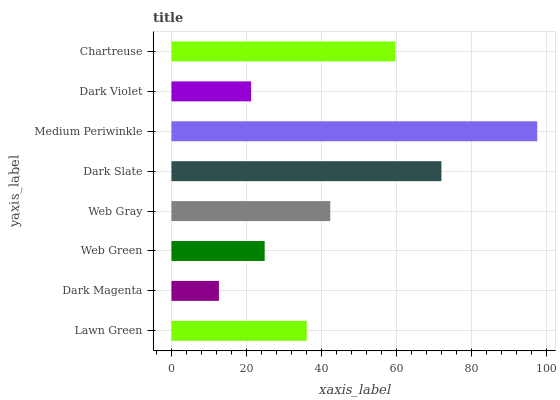Is Dark Magenta the minimum?
Answer yes or no. Yes. Is Medium Periwinkle the maximum?
Answer yes or no. Yes. Is Web Green the minimum?
Answer yes or no. No. Is Web Green the maximum?
Answer yes or no. No. Is Web Green greater than Dark Magenta?
Answer yes or no. Yes. Is Dark Magenta less than Web Green?
Answer yes or no. Yes. Is Dark Magenta greater than Web Green?
Answer yes or no. No. Is Web Green less than Dark Magenta?
Answer yes or no. No. Is Web Gray the high median?
Answer yes or no. Yes. Is Lawn Green the low median?
Answer yes or no. Yes. Is Lawn Green the high median?
Answer yes or no. No. Is Web Green the low median?
Answer yes or no. No. 